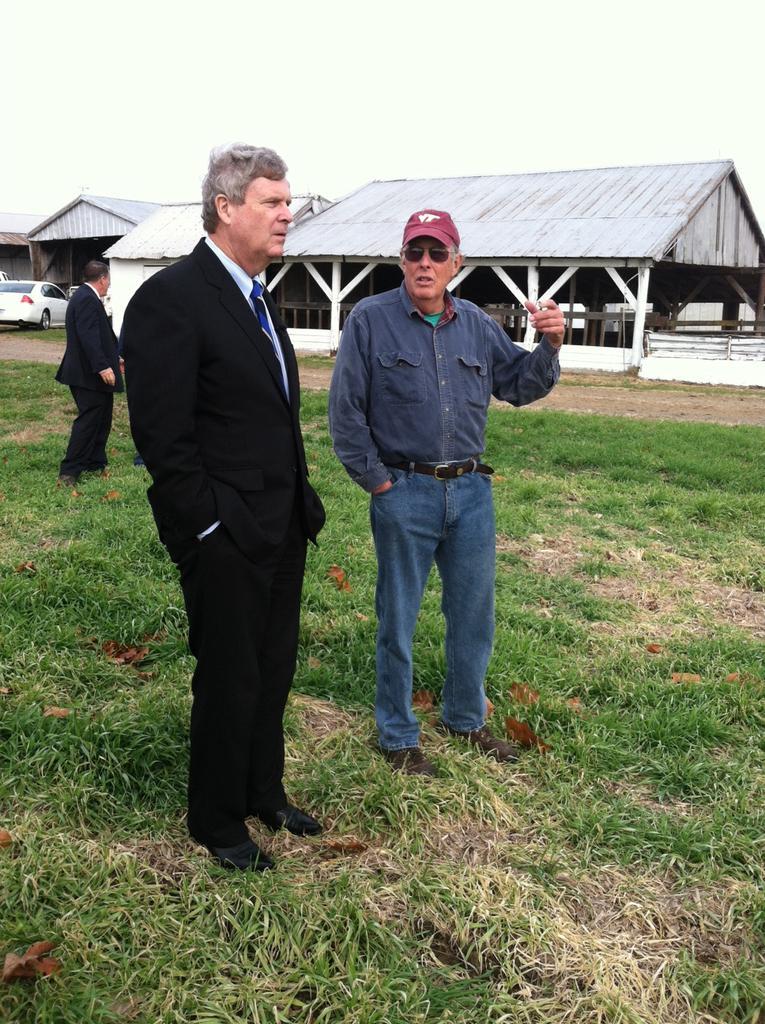Could you give a brief overview of what you see in this image? There are two men standing on the ground. In the background there is a person,vehicle,house,fence,grass and sky. 